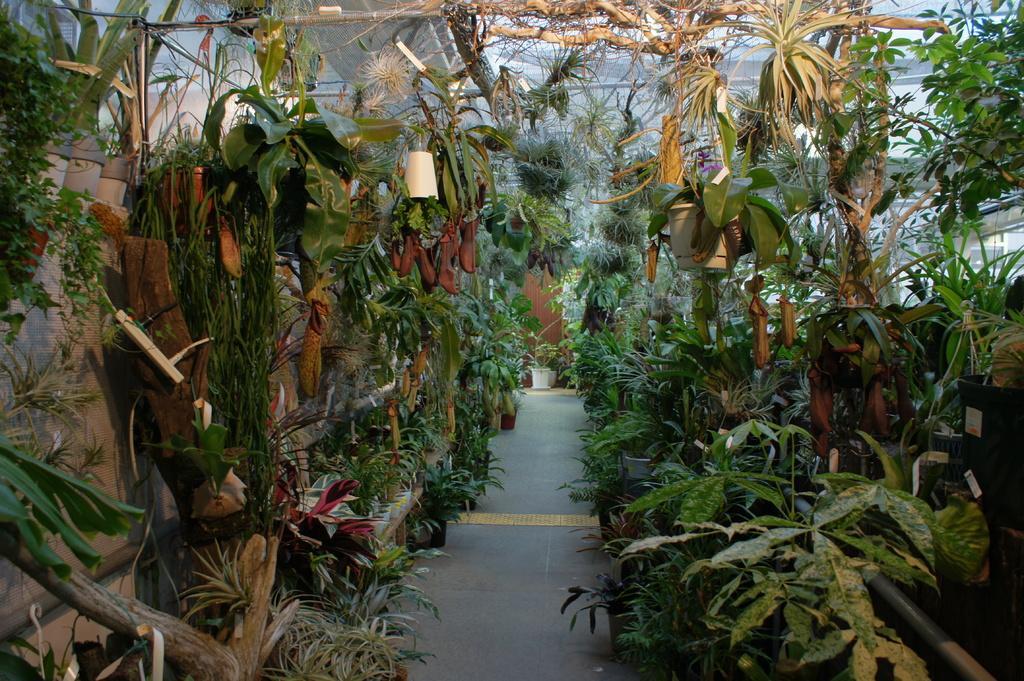Please provide a concise description of this image. In this image we can see the flower pots and also the plants. We can also see the path and a door in the background. 